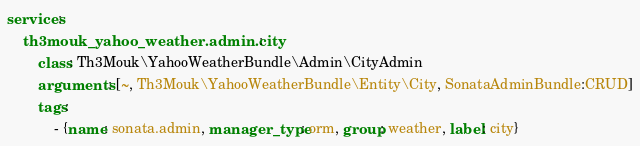Convert code to text. <code><loc_0><loc_0><loc_500><loc_500><_YAML_>services:
    th3mouk_yahoo_weather.admin.city:
        class: Th3Mouk\YahooWeatherBundle\Admin\CityAdmin
        arguments: [~, Th3Mouk\YahooWeatherBundle\Entity\City, SonataAdminBundle:CRUD]
        tags:
            - {name: sonata.admin, manager_type: orm, group: weather, label: city}
</code> 